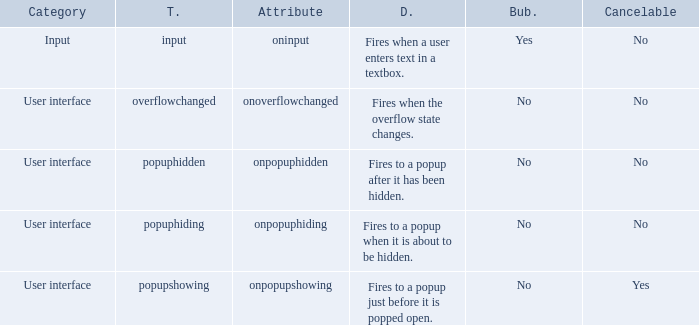What's the type with description being fires when the overflow state changes. Overflowchanged. 